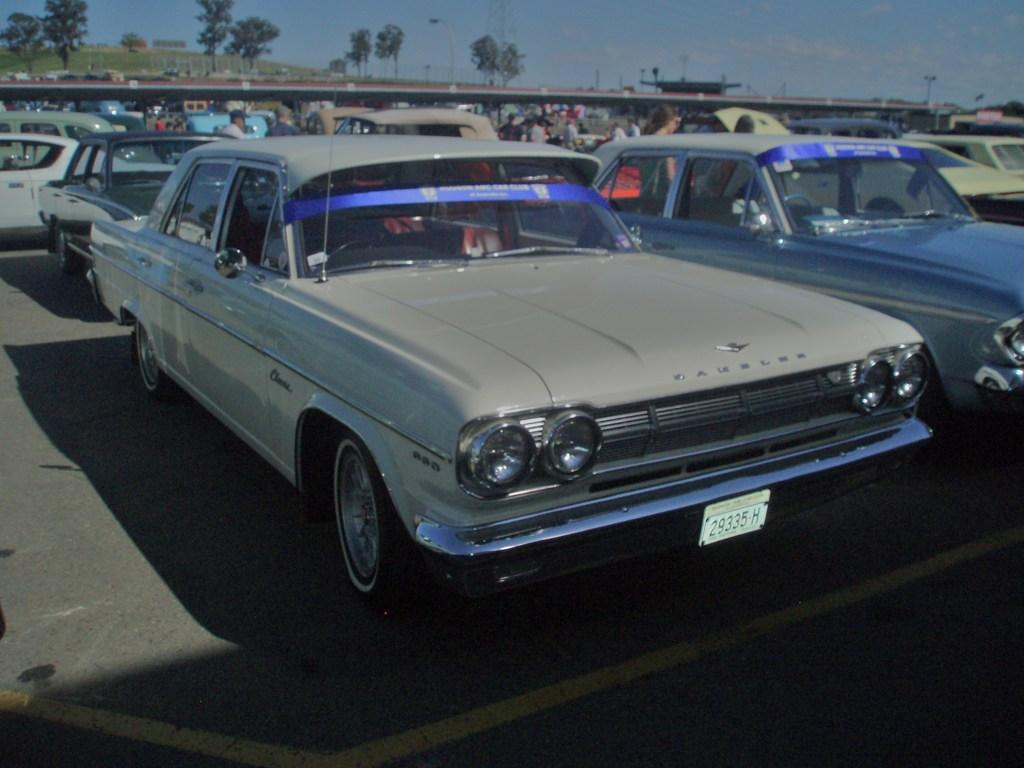What can be seen on the road in the image? There are vehicles parked on the road in the image. What else can be seen in the background of the image? There are people and trees visible in the background of the image. What is visible at the top of the image? The sky is visible at the top of the image. How does the heat affect the vehicles in the image? There is no information about the temperature or heat in the image, so it cannot be determined how it affects the vehicles. What type of muscle can be seen in the image? There are no muscles visible in the image; it features vehicles parked on the road and people in the background. 